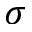Convert formula to latex. <formula><loc_0><loc_0><loc_500><loc_500>\sigma</formula> 